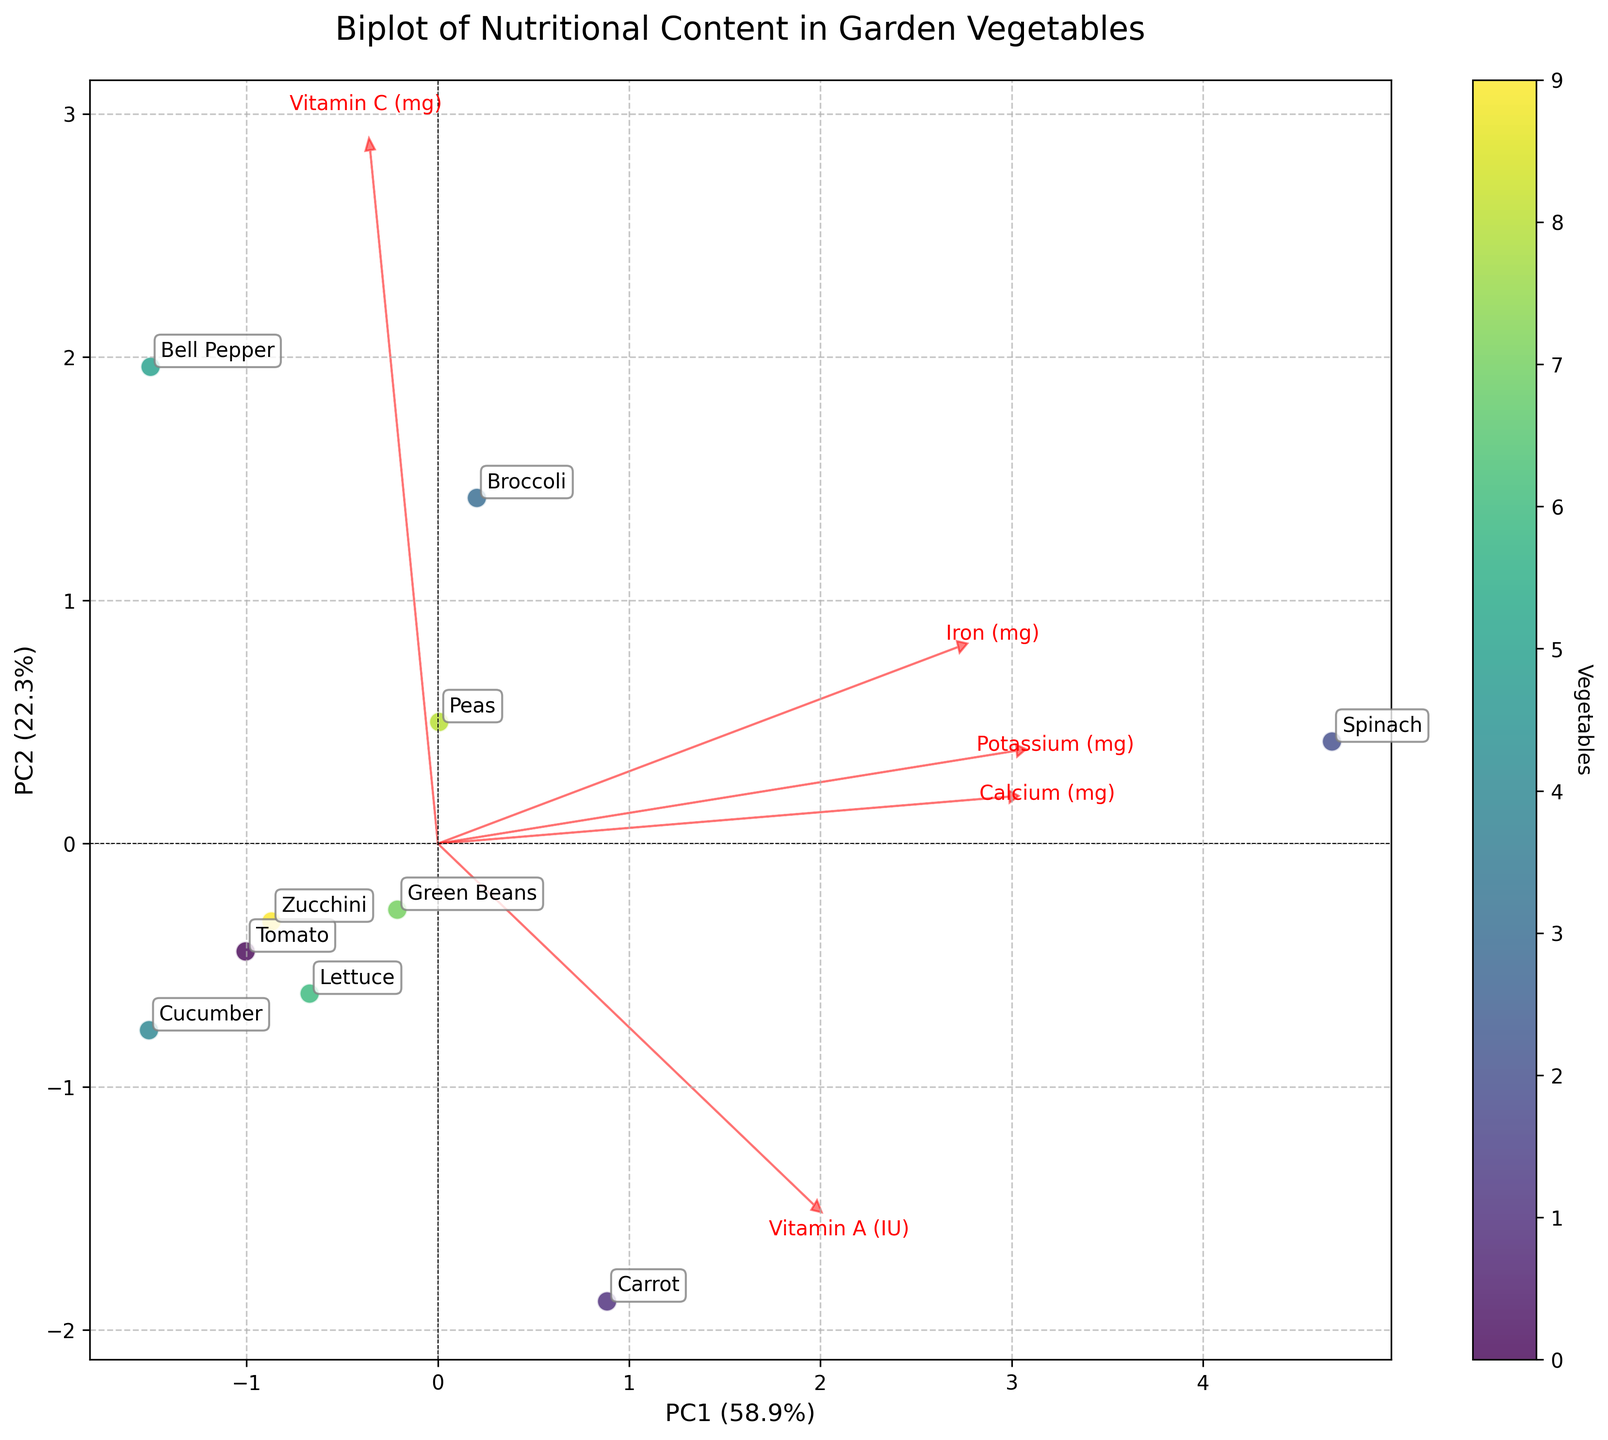What's the title of the figure? The title can be found at the top of the figure, and it provides a summary of the plot's content.
Answer: Biplot of Nutritional Content in Garden Vegetables How many axes are there, and what do they represent? There are two axes labeled PC1 and PC2. The x-axis (PC1) represents the first principal component explaining the highest variance in the data, and the y-axis (PC2) represents the second principal component explaining the second highest variance.
Answer: Two axes, PC1 and PC2 Which vegetable is furthest to the right of the figure? The furthest right position on the x-axis can be identified by observing the plot's rightmost data point labeled by a vegetable name.
Answer: Carrot Which nutrient vector points most towards the top right corner? The top right corner is the positive quadrant for both PC1 and PC2. The vector pointing most towards this direction signifies the nutrient loading highly on both principal components.
Answer: Vitamin A Which vegetable appears to be the richest in Iron and why? To determine which vegetable is richest in Iron, look for the data point closest to the Iron loading vector. Spinach is nearest to the Iron vector, indicating higher iron content.
Answer: Spinach How many vegetables are plotted in this biplot? The number of vegetables can be counted by identifying each labeled data point.
Answer: Ten Which two nutrients have their vectors pointing in nearly opposite directions? Vectors pointing in opposite directions signify that these nutrients have inverse relationships. By checking the directions of nutrient vectors, Vitamin A and Vitamin C point almost opposite to each other.
Answer: Vitamin A and Vitamin C Which axis explains more variance in the data? The x-axis (PC1) and the y-axis (PC2) have their explained variance percentages given in the axis labels. The axis with the higher percentage explains more variance.
Answer: PC1 Which vegetable is placed closest to the origin (0,0) in the plot? The vegetable closest to the origin is the one whose data point is near the center where both principal components are zero.
Answer: Cucumber Which nutrients contribute most to the separation along the y-axis? The nutrient vectors aligned closely with the y-axis (PC2) indicate nutrients contributing to separation along PC2. Vitamin C has the highest alignment with PC2.
Answer: Vitamin C 